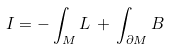Convert formula to latex. <formula><loc_0><loc_0><loc_500><loc_500>I = - \, { \int _ { M } } \, { L } \, + \, { \int _ { \partial M } } \, { B }</formula> 